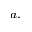Convert formula to latex. <formula><loc_0><loc_0><loc_500><loc_500>^ { a , }</formula> 